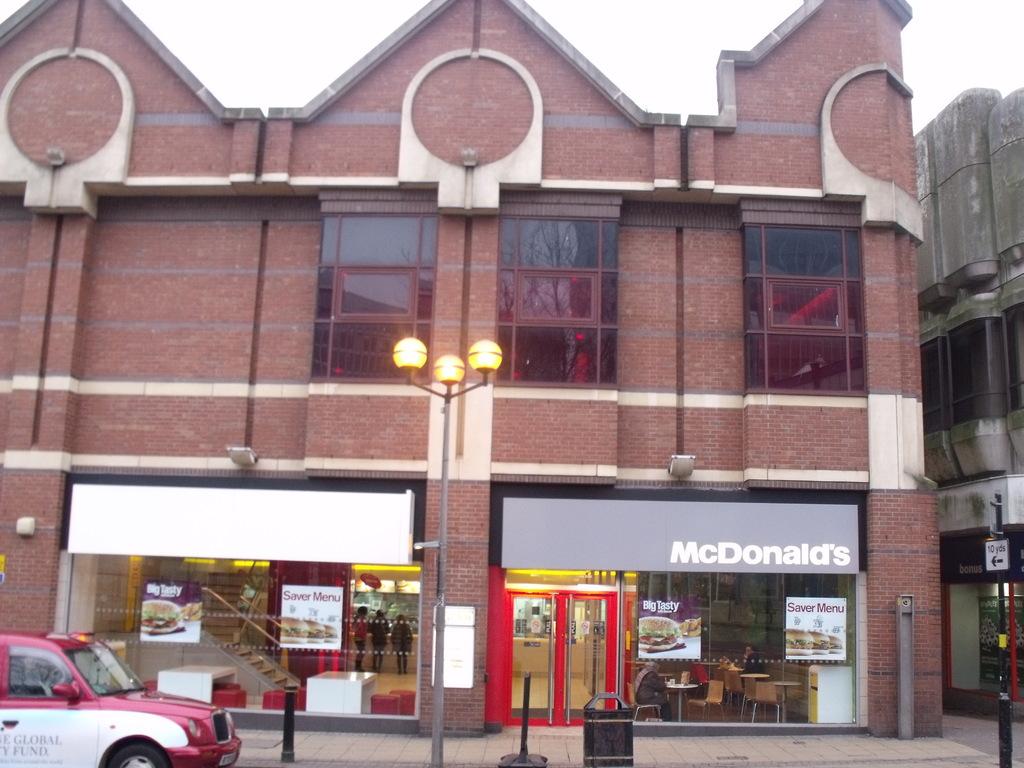What restaurant is shown?
Your response must be concise. Mcdonald's. What burger is being advertised on the far left picture?
Provide a short and direct response. Big tasty. 